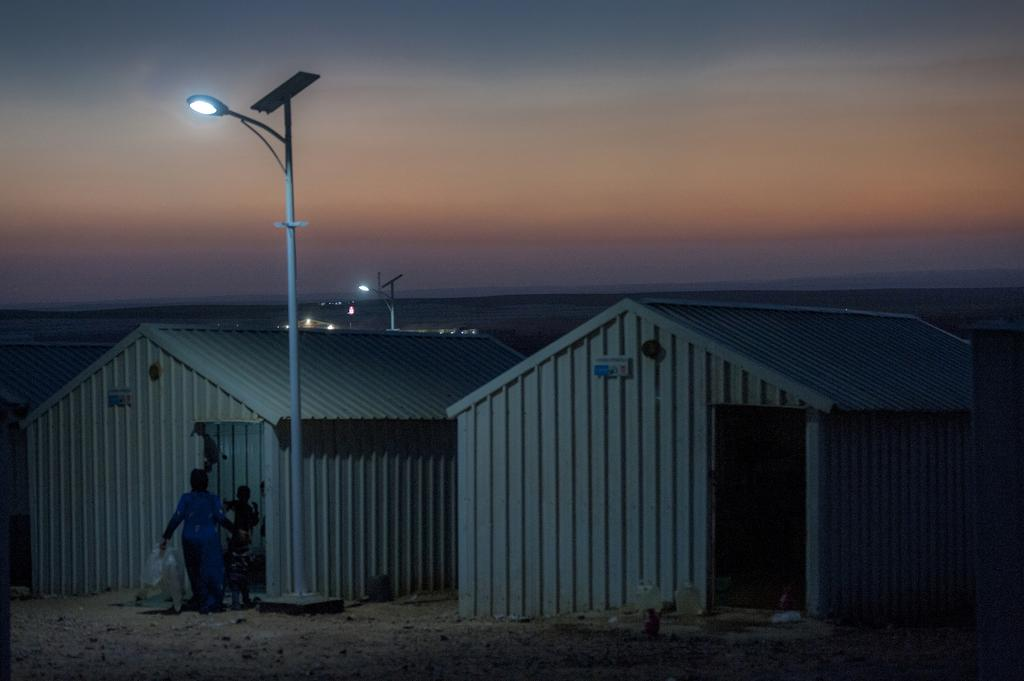What structures are located in the middle of the image? There are two iron sheds in the middle of the image. Who or what is on the left side of the image? A woman is present on the left side of the image. What type of lighting fixture can be seen in the image? There is a street lamp in the image. What is visible at the top of the image? The sky is visible at the top of the image. How many frogs are hopping around the iron sheds in the image? There are no frogs present in the image; it features two iron sheds, a woman, a street lamp, and a visible sky. What type of ocean can be seen in the background of the image? There is no ocean present in the image; it is set against a sky background. 